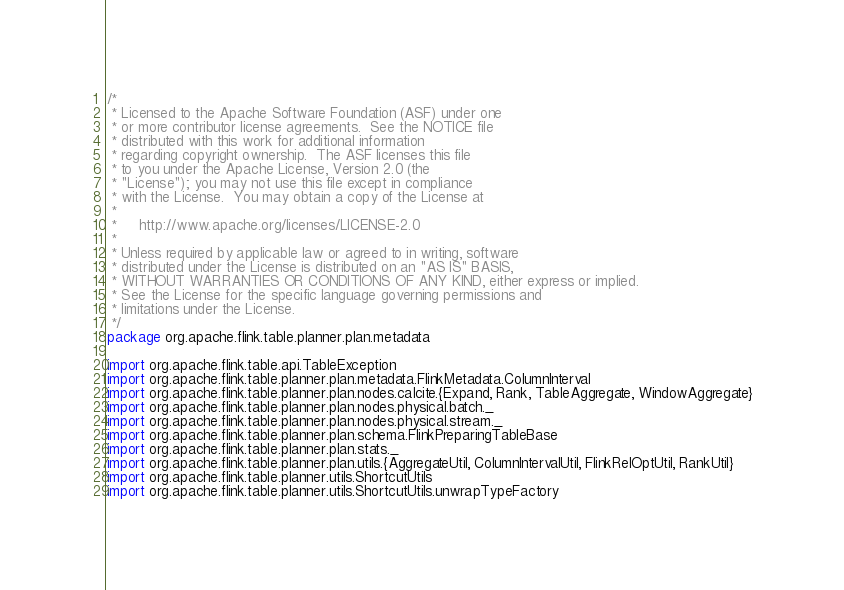Convert code to text. <code><loc_0><loc_0><loc_500><loc_500><_Scala_>/*
 * Licensed to the Apache Software Foundation (ASF) under one
 * or more contributor license agreements.  See the NOTICE file
 * distributed with this work for additional information
 * regarding copyright ownership.  The ASF licenses this file
 * to you under the Apache License, Version 2.0 (the
 * "License"); you may not use this file except in compliance
 * with the License.  You may obtain a copy of the License at
 *
 *     http://www.apache.org/licenses/LICENSE-2.0
 *
 * Unless required by applicable law or agreed to in writing, software
 * distributed under the License is distributed on an "AS IS" BASIS,
 * WITHOUT WARRANTIES OR CONDITIONS OF ANY KIND, either express or implied.
 * See the License for the specific language governing permissions and
 * limitations under the License.
 */
package org.apache.flink.table.planner.plan.metadata

import org.apache.flink.table.api.TableException
import org.apache.flink.table.planner.plan.metadata.FlinkMetadata.ColumnInterval
import org.apache.flink.table.planner.plan.nodes.calcite.{Expand, Rank, TableAggregate, WindowAggregate}
import org.apache.flink.table.planner.plan.nodes.physical.batch._
import org.apache.flink.table.planner.plan.nodes.physical.stream._
import org.apache.flink.table.planner.plan.schema.FlinkPreparingTableBase
import org.apache.flink.table.planner.plan.stats._
import org.apache.flink.table.planner.plan.utils.{AggregateUtil, ColumnIntervalUtil, FlinkRelOptUtil, RankUtil}
import org.apache.flink.table.planner.utils.ShortcutUtils
import org.apache.flink.table.planner.utils.ShortcutUtils.unwrapTypeFactory</code> 